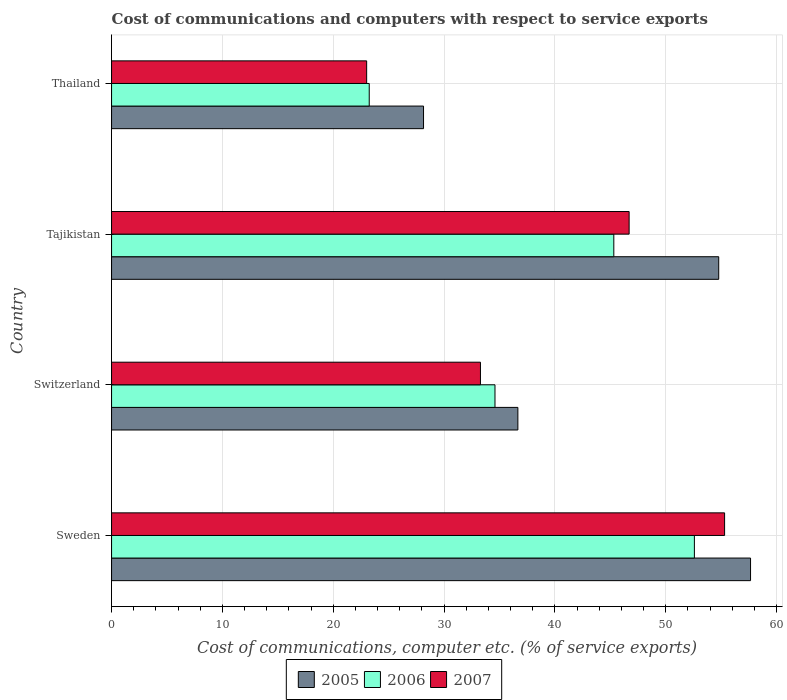How many groups of bars are there?
Your response must be concise. 4. Are the number of bars per tick equal to the number of legend labels?
Provide a succinct answer. Yes. Are the number of bars on each tick of the Y-axis equal?
Provide a short and direct response. Yes. What is the label of the 3rd group of bars from the top?
Give a very brief answer. Switzerland. What is the cost of communications and computers in 2006 in Switzerland?
Provide a succinct answer. 34.6. Across all countries, what is the maximum cost of communications and computers in 2006?
Provide a short and direct response. 52.59. Across all countries, what is the minimum cost of communications and computers in 2007?
Ensure brevity in your answer.  23.02. In which country was the cost of communications and computers in 2005 maximum?
Your answer should be very brief. Sweden. In which country was the cost of communications and computers in 2007 minimum?
Offer a very short reply. Thailand. What is the total cost of communications and computers in 2006 in the graph?
Provide a succinct answer. 155.75. What is the difference between the cost of communications and computers in 2005 in Tajikistan and that in Thailand?
Your response must be concise. 26.64. What is the difference between the cost of communications and computers in 2005 in Thailand and the cost of communications and computers in 2006 in Tajikistan?
Your answer should be very brief. -17.17. What is the average cost of communications and computers in 2005 per country?
Ensure brevity in your answer.  44.31. What is the difference between the cost of communications and computers in 2006 and cost of communications and computers in 2007 in Thailand?
Provide a short and direct response. 0.23. In how many countries, is the cost of communications and computers in 2007 greater than 52 %?
Offer a terse response. 1. What is the ratio of the cost of communications and computers in 2005 in Switzerland to that in Tajikistan?
Give a very brief answer. 0.67. Is the cost of communications and computers in 2007 in Sweden less than that in Tajikistan?
Ensure brevity in your answer.  No. What is the difference between the highest and the second highest cost of communications and computers in 2006?
Keep it short and to the point. 7.27. What is the difference between the highest and the lowest cost of communications and computers in 2007?
Offer a very short reply. 32.3. In how many countries, is the cost of communications and computers in 2006 greater than the average cost of communications and computers in 2006 taken over all countries?
Your response must be concise. 2. Is the sum of the cost of communications and computers in 2006 in Switzerland and Tajikistan greater than the maximum cost of communications and computers in 2007 across all countries?
Ensure brevity in your answer.  Yes. What does the 1st bar from the top in Switzerland represents?
Your response must be concise. 2007. What does the 3rd bar from the bottom in Switzerland represents?
Your answer should be very brief. 2007. Is it the case that in every country, the sum of the cost of communications and computers in 2007 and cost of communications and computers in 2006 is greater than the cost of communications and computers in 2005?
Provide a succinct answer. Yes. Are all the bars in the graph horizontal?
Offer a very short reply. Yes. How many countries are there in the graph?
Offer a very short reply. 4. Does the graph contain grids?
Your response must be concise. Yes. Where does the legend appear in the graph?
Ensure brevity in your answer.  Bottom center. What is the title of the graph?
Keep it short and to the point. Cost of communications and computers with respect to service exports. What is the label or title of the X-axis?
Give a very brief answer. Cost of communications, computer etc. (% of service exports). What is the label or title of the Y-axis?
Give a very brief answer. Country. What is the Cost of communications, computer etc. (% of service exports) in 2005 in Sweden?
Offer a terse response. 57.66. What is the Cost of communications, computer etc. (% of service exports) in 2006 in Sweden?
Make the answer very short. 52.59. What is the Cost of communications, computer etc. (% of service exports) of 2007 in Sweden?
Make the answer very short. 55.32. What is the Cost of communications, computer etc. (% of service exports) in 2005 in Switzerland?
Your answer should be compact. 36.66. What is the Cost of communications, computer etc. (% of service exports) of 2006 in Switzerland?
Give a very brief answer. 34.6. What is the Cost of communications, computer etc. (% of service exports) of 2007 in Switzerland?
Give a very brief answer. 33.29. What is the Cost of communications, computer etc. (% of service exports) in 2005 in Tajikistan?
Your answer should be compact. 54.78. What is the Cost of communications, computer etc. (% of service exports) of 2006 in Tajikistan?
Make the answer very short. 45.32. What is the Cost of communications, computer etc. (% of service exports) of 2007 in Tajikistan?
Ensure brevity in your answer.  46.7. What is the Cost of communications, computer etc. (% of service exports) in 2005 in Thailand?
Offer a terse response. 28.15. What is the Cost of communications, computer etc. (% of service exports) of 2006 in Thailand?
Give a very brief answer. 23.25. What is the Cost of communications, computer etc. (% of service exports) in 2007 in Thailand?
Provide a succinct answer. 23.02. Across all countries, what is the maximum Cost of communications, computer etc. (% of service exports) of 2005?
Ensure brevity in your answer.  57.66. Across all countries, what is the maximum Cost of communications, computer etc. (% of service exports) in 2006?
Your answer should be compact. 52.59. Across all countries, what is the maximum Cost of communications, computer etc. (% of service exports) of 2007?
Ensure brevity in your answer.  55.32. Across all countries, what is the minimum Cost of communications, computer etc. (% of service exports) of 2005?
Your response must be concise. 28.15. Across all countries, what is the minimum Cost of communications, computer etc. (% of service exports) of 2006?
Provide a short and direct response. 23.25. Across all countries, what is the minimum Cost of communications, computer etc. (% of service exports) in 2007?
Ensure brevity in your answer.  23.02. What is the total Cost of communications, computer etc. (% of service exports) in 2005 in the graph?
Your response must be concise. 177.25. What is the total Cost of communications, computer etc. (% of service exports) of 2006 in the graph?
Keep it short and to the point. 155.75. What is the total Cost of communications, computer etc. (% of service exports) in 2007 in the graph?
Provide a short and direct response. 158.32. What is the difference between the Cost of communications, computer etc. (% of service exports) in 2005 in Sweden and that in Switzerland?
Ensure brevity in your answer.  20.99. What is the difference between the Cost of communications, computer etc. (% of service exports) in 2006 in Sweden and that in Switzerland?
Make the answer very short. 17.99. What is the difference between the Cost of communications, computer etc. (% of service exports) in 2007 in Sweden and that in Switzerland?
Offer a terse response. 22.03. What is the difference between the Cost of communications, computer etc. (% of service exports) of 2005 in Sweden and that in Tajikistan?
Provide a succinct answer. 2.87. What is the difference between the Cost of communications, computer etc. (% of service exports) of 2006 in Sweden and that in Tajikistan?
Your answer should be very brief. 7.27. What is the difference between the Cost of communications, computer etc. (% of service exports) of 2007 in Sweden and that in Tajikistan?
Give a very brief answer. 8.61. What is the difference between the Cost of communications, computer etc. (% of service exports) in 2005 in Sweden and that in Thailand?
Make the answer very short. 29.51. What is the difference between the Cost of communications, computer etc. (% of service exports) of 2006 in Sweden and that in Thailand?
Provide a succinct answer. 29.34. What is the difference between the Cost of communications, computer etc. (% of service exports) of 2007 in Sweden and that in Thailand?
Offer a very short reply. 32.3. What is the difference between the Cost of communications, computer etc. (% of service exports) of 2005 in Switzerland and that in Tajikistan?
Give a very brief answer. -18.12. What is the difference between the Cost of communications, computer etc. (% of service exports) in 2006 in Switzerland and that in Tajikistan?
Ensure brevity in your answer.  -10.72. What is the difference between the Cost of communications, computer etc. (% of service exports) in 2007 in Switzerland and that in Tajikistan?
Ensure brevity in your answer.  -13.42. What is the difference between the Cost of communications, computer etc. (% of service exports) in 2005 in Switzerland and that in Thailand?
Give a very brief answer. 8.51. What is the difference between the Cost of communications, computer etc. (% of service exports) in 2006 in Switzerland and that in Thailand?
Offer a very short reply. 11.35. What is the difference between the Cost of communications, computer etc. (% of service exports) of 2007 in Switzerland and that in Thailand?
Keep it short and to the point. 10.27. What is the difference between the Cost of communications, computer etc. (% of service exports) of 2005 in Tajikistan and that in Thailand?
Give a very brief answer. 26.64. What is the difference between the Cost of communications, computer etc. (% of service exports) in 2006 in Tajikistan and that in Thailand?
Offer a very short reply. 22.07. What is the difference between the Cost of communications, computer etc. (% of service exports) of 2007 in Tajikistan and that in Thailand?
Offer a terse response. 23.68. What is the difference between the Cost of communications, computer etc. (% of service exports) of 2005 in Sweden and the Cost of communications, computer etc. (% of service exports) of 2006 in Switzerland?
Provide a short and direct response. 23.06. What is the difference between the Cost of communications, computer etc. (% of service exports) in 2005 in Sweden and the Cost of communications, computer etc. (% of service exports) in 2007 in Switzerland?
Your answer should be compact. 24.37. What is the difference between the Cost of communications, computer etc. (% of service exports) in 2006 in Sweden and the Cost of communications, computer etc. (% of service exports) in 2007 in Switzerland?
Ensure brevity in your answer.  19.3. What is the difference between the Cost of communications, computer etc. (% of service exports) of 2005 in Sweden and the Cost of communications, computer etc. (% of service exports) of 2006 in Tajikistan?
Give a very brief answer. 12.34. What is the difference between the Cost of communications, computer etc. (% of service exports) of 2005 in Sweden and the Cost of communications, computer etc. (% of service exports) of 2007 in Tajikistan?
Your response must be concise. 10.96. What is the difference between the Cost of communications, computer etc. (% of service exports) in 2006 in Sweden and the Cost of communications, computer etc. (% of service exports) in 2007 in Tajikistan?
Make the answer very short. 5.89. What is the difference between the Cost of communications, computer etc. (% of service exports) of 2005 in Sweden and the Cost of communications, computer etc. (% of service exports) of 2006 in Thailand?
Keep it short and to the point. 34.41. What is the difference between the Cost of communications, computer etc. (% of service exports) of 2005 in Sweden and the Cost of communications, computer etc. (% of service exports) of 2007 in Thailand?
Make the answer very short. 34.64. What is the difference between the Cost of communications, computer etc. (% of service exports) in 2006 in Sweden and the Cost of communications, computer etc. (% of service exports) in 2007 in Thailand?
Your response must be concise. 29.57. What is the difference between the Cost of communications, computer etc. (% of service exports) of 2005 in Switzerland and the Cost of communications, computer etc. (% of service exports) of 2006 in Tajikistan?
Give a very brief answer. -8.66. What is the difference between the Cost of communications, computer etc. (% of service exports) in 2005 in Switzerland and the Cost of communications, computer etc. (% of service exports) in 2007 in Tajikistan?
Your answer should be very brief. -10.04. What is the difference between the Cost of communications, computer etc. (% of service exports) of 2006 in Switzerland and the Cost of communications, computer etc. (% of service exports) of 2007 in Tajikistan?
Offer a very short reply. -12.1. What is the difference between the Cost of communications, computer etc. (% of service exports) in 2005 in Switzerland and the Cost of communications, computer etc. (% of service exports) in 2006 in Thailand?
Provide a short and direct response. 13.41. What is the difference between the Cost of communications, computer etc. (% of service exports) in 2005 in Switzerland and the Cost of communications, computer etc. (% of service exports) in 2007 in Thailand?
Your answer should be compact. 13.64. What is the difference between the Cost of communications, computer etc. (% of service exports) of 2006 in Switzerland and the Cost of communications, computer etc. (% of service exports) of 2007 in Thailand?
Your answer should be compact. 11.58. What is the difference between the Cost of communications, computer etc. (% of service exports) in 2005 in Tajikistan and the Cost of communications, computer etc. (% of service exports) in 2006 in Thailand?
Provide a succinct answer. 31.53. What is the difference between the Cost of communications, computer etc. (% of service exports) in 2005 in Tajikistan and the Cost of communications, computer etc. (% of service exports) in 2007 in Thailand?
Make the answer very short. 31.77. What is the difference between the Cost of communications, computer etc. (% of service exports) of 2006 in Tajikistan and the Cost of communications, computer etc. (% of service exports) of 2007 in Thailand?
Keep it short and to the point. 22.3. What is the average Cost of communications, computer etc. (% of service exports) of 2005 per country?
Give a very brief answer. 44.31. What is the average Cost of communications, computer etc. (% of service exports) of 2006 per country?
Provide a succinct answer. 38.94. What is the average Cost of communications, computer etc. (% of service exports) of 2007 per country?
Ensure brevity in your answer.  39.58. What is the difference between the Cost of communications, computer etc. (% of service exports) in 2005 and Cost of communications, computer etc. (% of service exports) in 2006 in Sweden?
Offer a terse response. 5.07. What is the difference between the Cost of communications, computer etc. (% of service exports) of 2005 and Cost of communications, computer etc. (% of service exports) of 2007 in Sweden?
Your answer should be very brief. 2.34. What is the difference between the Cost of communications, computer etc. (% of service exports) of 2006 and Cost of communications, computer etc. (% of service exports) of 2007 in Sweden?
Make the answer very short. -2.73. What is the difference between the Cost of communications, computer etc. (% of service exports) in 2005 and Cost of communications, computer etc. (% of service exports) in 2006 in Switzerland?
Provide a short and direct response. 2.07. What is the difference between the Cost of communications, computer etc. (% of service exports) of 2005 and Cost of communications, computer etc. (% of service exports) of 2007 in Switzerland?
Ensure brevity in your answer.  3.38. What is the difference between the Cost of communications, computer etc. (% of service exports) of 2006 and Cost of communications, computer etc. (% of service exports) of 2007 in Switzerland?
Your answer should be compact. 1.31. What is the difference between the Cost of communications, computer etc. (% of service exports) in 2005 and Cost of communications, computer etc. (% of service exports) in 2006 in Tajikistan?
Keep it short and to the point. 9.47. What is the difference between the Cost of communications, computer etc. (% of service exports) of 2005 and Cost of communications, computer etc. (% of service exports) of 2007 in Tajikistan?
Keep it short and to the point. 8.08. What is the difference between the Cost of communications, computer etc. (% of service exports) of 2006 and Cost of communications, computer etc. (% of service exports) of 2007 in Tajikistan?
Keep it short and to the point. -1.38. What is the difference between the Cost of communications, computer etc. (% of service exports) in 2005 and Cost of communications, computer etc. (% of service exports) in 2006 in Thailand?
Ensure brevity in your answer.  4.9. What is the difference between the Cost of communications, computer etc. (% of service exports) of 2005 and Cost of communications, computer etc. (% of service exports) of 2007 in Thailand?
Your answer should be very brief. 5.13. What is the difference between the Cost of communications, computer etc. (% of service exports) of 2006 and Cost of communications, computer etc. (% of service exports) of 2007 in Thailand?
Your answer should be compact. 0.23. What is the ratio of the Cost of communications, computer etc. (% of service exports) of 2005 in Sweden to that in Switzerland?
Offer a terse response. 1.57. What is the ratio of the Cost of communications, computer etc. (% of service exports) of 2006 in Sweden to that in Switzerland?
Provide a short and direct response. 1.52. What is the ratio of the Cost of communications, computer etc. (% of service exports) of 2007 in Sweden to that in Switzerland?
Provide a short and direct response. 1.66. What is the ratio of the Cost of communications, computer etc. (% of service exports) of 2005 in Sweden to that in Tajikistan?
Make the answer very short. 1.05. What is the ratio of the Cost of communications, computer etc. (% of service exports) of 2006 in Sweden to that in Tajikistan?
Offer a terse response. 1.16. What is the ratio of the Cost of communications, computer etc. (% of service exports) in 2007 in Sweden to that in Tajikistan?
Offer a terse response. 1.18. What is the ratio of the Cost of communications, computer etc. (% of service exports) in 2005 in Sweden to that in Thailand?
Offer a terse response. 2.05. What is the ratio of the Cost of communications, computer etc. (% of service exports) in 2006 in Sweden to that in Thailand?
Make the answer very short. 2.26. What is the ratio of the Cost of communications, computer etc. (% of service exports) of 2007 in Sweden to that in Thailand?
Your answer should be very brief. 2.4. What is the ratio of the Cost of communications, computer etc. (% of service exports) in 2005 in Switzerland to that in Tajikistan?
Keep it short and to the point. 0.67. What is the ratio of the Cost of communications, computer etc. (% of service exports) of 2006 in Switzerland to that in Tajikistan?
Your response must be concise. 0.76. What is the ratio of the Cost of communications, computer etc. (% of service exports) of 2007 in Switzerland to that in Tajikistan?
Offer a very short reply. 0.71. What is the ratio of the Cost of communications, computer etc. (% of service exports) in 2005 in Switzerland to that in Thailand?
Give a very brief answer. 1.3. What is the ratio of the Cost of communications, computer etc. (% of service exports) in 2006 in Switzerland to that in Thailand?
Offer a terse response. 1.49. What is the ratio of the Cost of communications, computer etc. (% of service exports) in 2007 in Switzerland to that in Thailand?
Offer a terse response. 1.45. What is the ratio of the Cost of communications, computer etc. (% of service exports) in 2005 in Tajikistan to that in Thailand?
Your answer should be compact. 1.95. What is the ratio of the Cost of communications, computer etc. (% of service exports) in 2006 in Tajikistan to that in Thailand?
Offer a very short reply. 1.95. What is the ratio of the Cost of communications, computer etc. (% of service exports) in 2007 in Tajikistan to that in Thailand?
Your response must be concise. 2.03. What is the difference between the highest and the second highest Cost of communications, computer etc. (% of service exports) in 2005?
Provide a succinct answer. 2.87. What is the difference between the highest and the second highest Cost of communications, computer etc. (% of service exports) of 2006?
Your response must be concise. 7.27. What is the difference between the highest and the second highest Cost of communications, computer etc. (% of service exports) in 2007?
Provide a short and direct response. 8.61. What is the difference between the highest and the lowest Cost of communications, computer etc. (% of service exports) of 2005?
Offer a very short reply. 29.51. What is the difference between the highest and the lowest Cost of communications, computer etc. (% of service exports) in 2006?
Your answer should be compact. 29.34. What is the difference between the highest and the lowest Cost of communications, computer etc. (% of service exports) of 2007?
Provide a succinct answer. 32.3. 